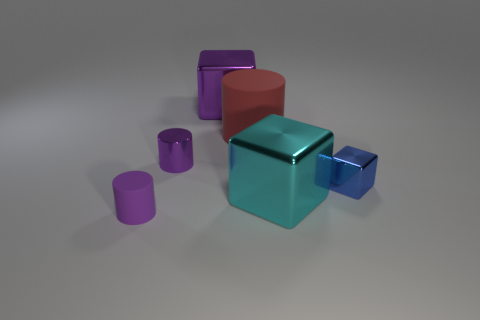Add 2 purple cylinders. How many objects exist? 8 Subtract all large objects. Subtract all big cylinders. How many objects are left? 2 Add 3 metal cylinders. How many metal cylinders are left? 4 Add 2 tiny shiny cylinders. How many tiny shiny cylinders exist? 3 Subtract 0 yellow blocks. How many objects are left? 6 